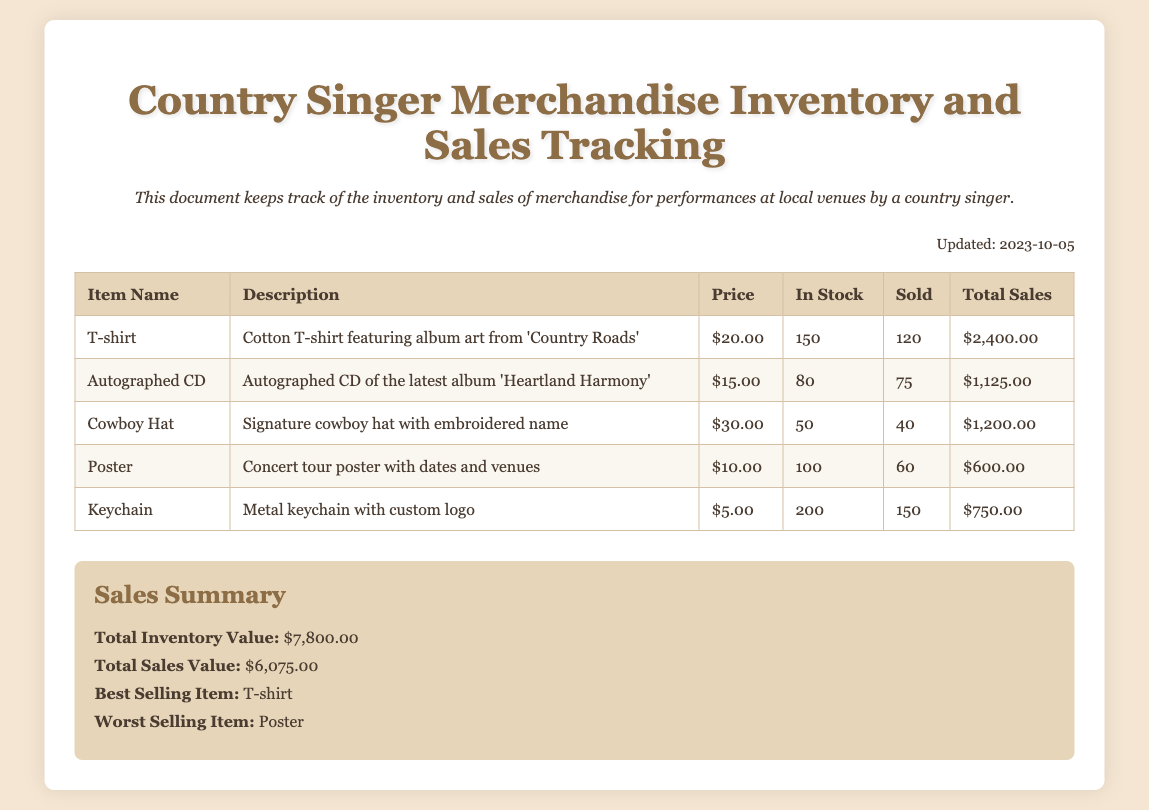What is the title of the document? The title of the document is specified in the header as "Country Singer Merchandise Inventory and Sales Tracking."
Answer: Country Singer Merchandise Inventory and Sales Tracking When was the document last updated? The document provides an updated date mentioned in the text, which is "Updated: 2023-10-05."
Answer: 2023-10-05 How many T-shirts are currently in stock? The number of T-shirts in stock is provided in the table under the "In Stock" column, which is "150."
Answer: 150 What is the total sales value? The total sales value is calculated and presented in the summary section as "$6,075.00."
Answer: $6,075.00 Which item is the best selling? The summary states that the best selling item is "T-shirt."
Answer: T-shirt What is the price of the Autographed CD? The price for the Autographed CD is clearly indicated in the table as "$15.00."
Answer: $15.00 How many Cowboy Hats have been sold? The number of Cowboy Hats sold can be found in the table under the "Sold" column, which is "40."
Answer: 40 What is the total inventory value? The total inventory value is provided in the summary and is "$7,800.00."
Answer: $7,800.00 What is the worst selling item? According to the summary section, the worst selling item is "Poster."
Answer: Poster 